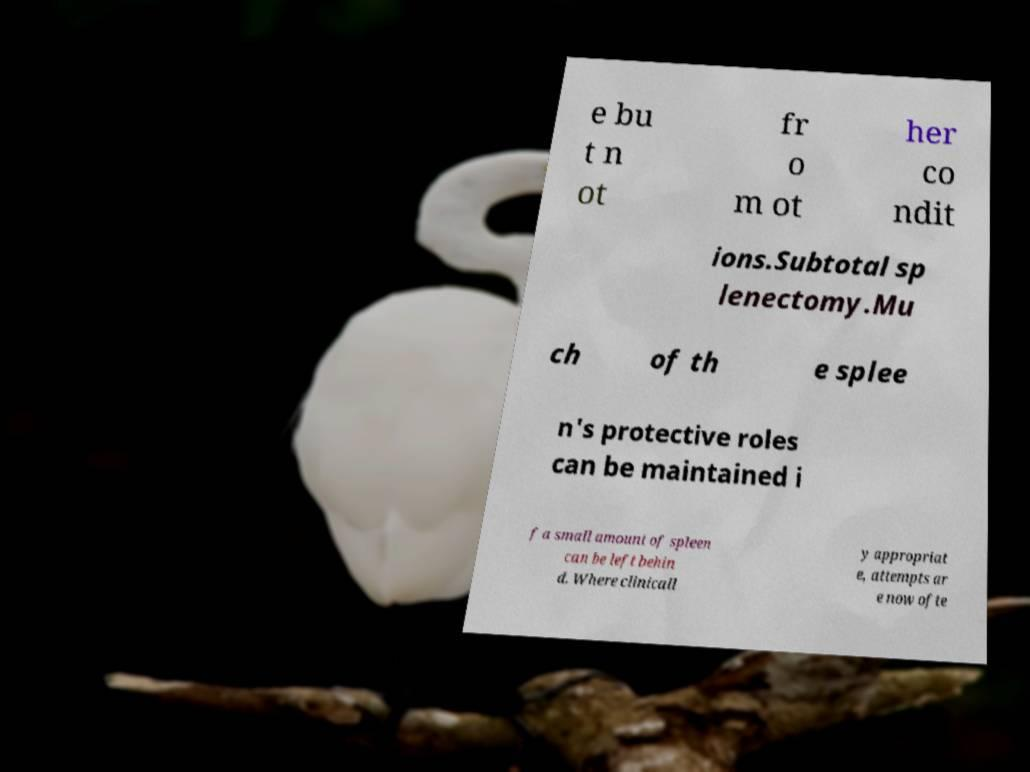Could you assist in decoding the text presented in this image and type it out clearly? e bu t n ot fr o m ot her co ndit ions.Subtotal sp lenectomy.Mu ch of th e splee n's protective roles can be maintained i f a small amount of spleen can be left behin d. Where clinicall y appropriat e, attempts ar e now ofte 